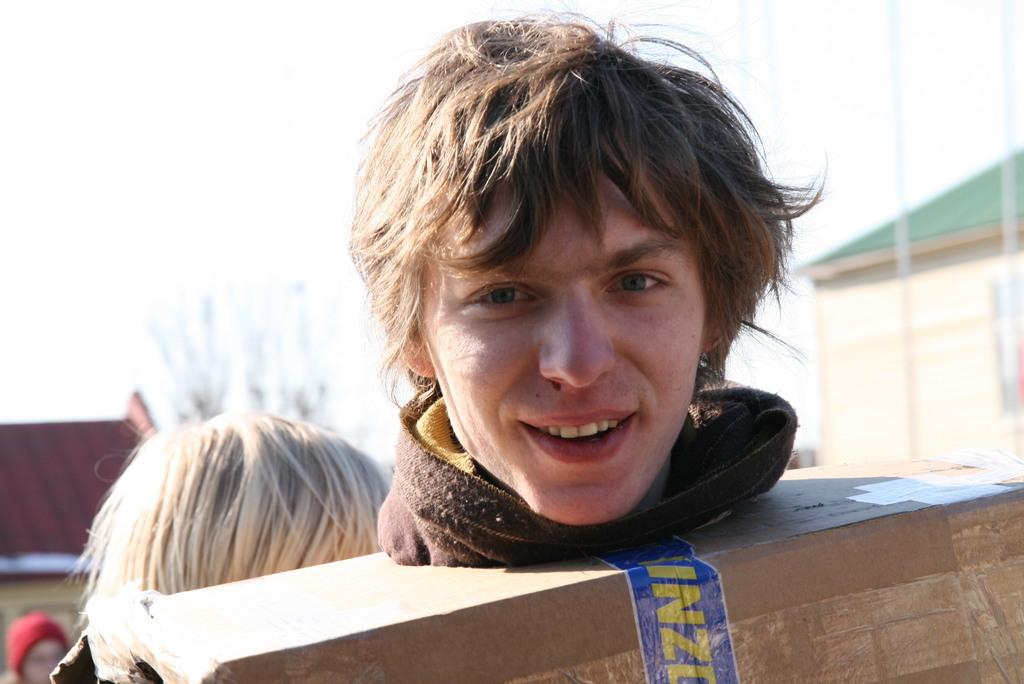What is the man in the image wearing? The man is wearing a carton box in the image. Can you describe the woman's position in relation to the man? The woman is behind the man in the image. What can be seen in the distance in the image? There are buildings in the background of the image. What type of wine is being served in the image? There is no wine present in the image; it features a man wearing a carton box and a woman behind him. What material is the stem of the glass in the image made of? There is no glass or stem present in the image. 